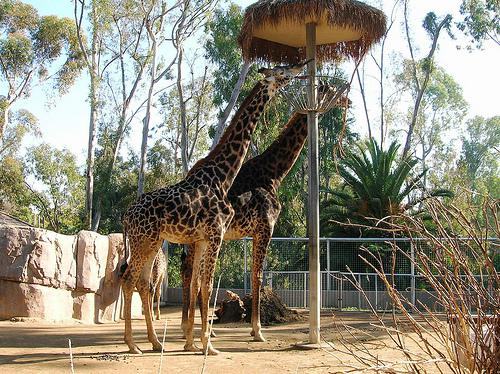Question: how many giraffes are in the image?
Choices:
A. 2.
B. 3.
C. 5.
D. 0.
Answer with the letter. Answer: B Question: what color are the rocks be hide the giraffes?
Choices:
A. Gray.
B. White.
C. Tan.
D. Black.
Answer with the letter. Answer: C 